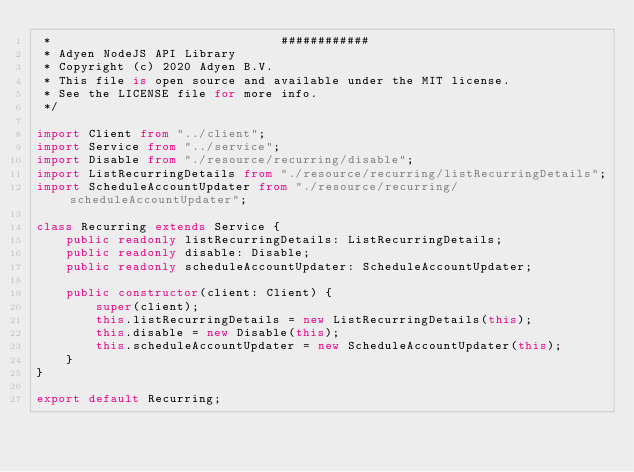<code> <loc_0><loc_0><loc_500><loc_500><_TypeScript_> *                               ############
 * Adyen NodeJS API Library
 * Copyright (c) 2020 Adyen B.V.
 * This file is open source and available under the MIT license.
 * See the LICENSE file for more info.
 */

import Client from "../client";
import Service from "../service";
import Disable from "./resource/recurring/disable";
import ListRecurringDetails from "./resource/recurring/listRecurringDetails";
import ScheduleAccountUpdater from "./resource/recurring/scheduleAccountUpdater";

class Recurring extends Service {
    public readonly listRecurringDetails: ListRecurringDetails;
    public readonly disable: Disable;
    public readonly scheduleAccountUpdater: ScheduleAccountUpdater;

    public constructor(client: Client) {
        super(client);
        this.listRecurringDetails = new ListRecurringDetails(this);
        this.disable = new Disable(this);
        this.scheduleAccountUpdater = new ScheduleAccountUpdater(this);
    }
}

export default Recurring;
</code> 